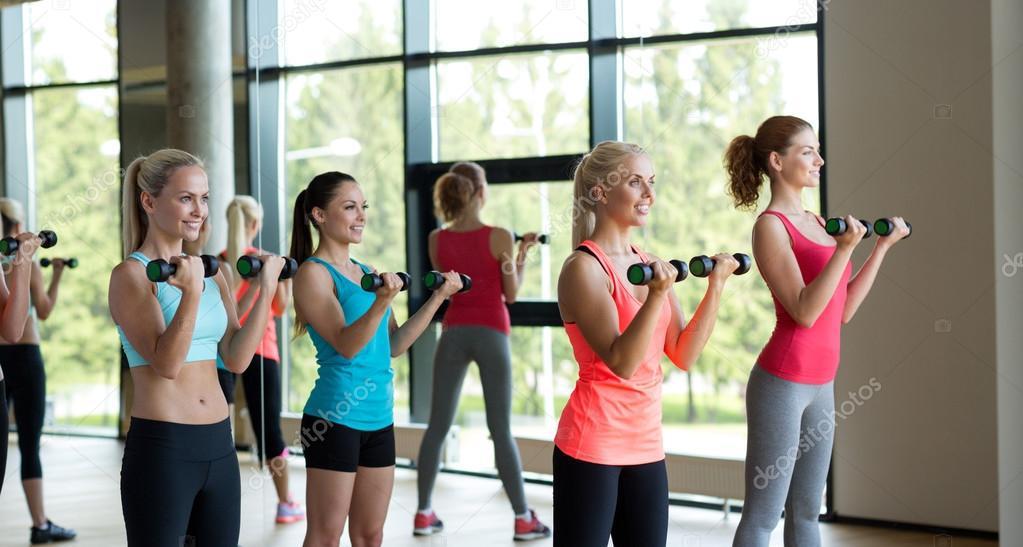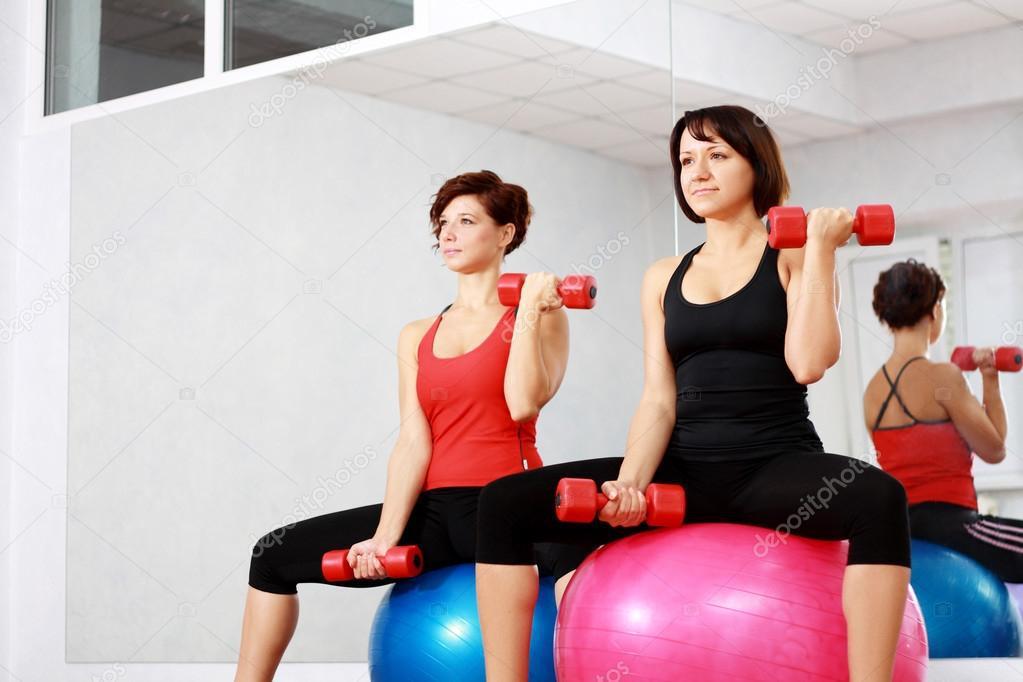The first image is the image on the left, the second image is the image on the right. Evaluate the accuracy of this statement regarding the images: "The right image includes two people sitting facing forward, each with one dumbbell in a lowered hand and one in a raised hand.". Is it true? Answer yes or no. Yes. The first image is the image on the left, the second image is the image on the right. Evaluate the accuracy of this statement regarding the images: "The left and right image contains a total of five people lifting weights.". Is it true? Answer yes or no. No. 